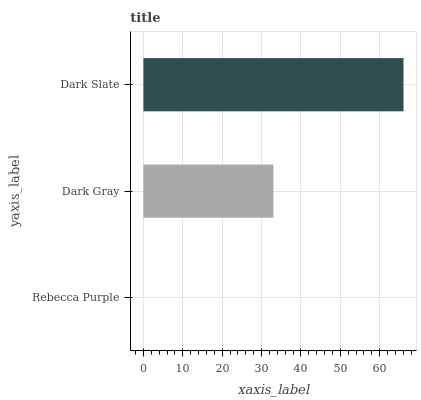Is Rebecca Purple the minimum?
Answer yes or no. Yes. Is Dark Slate the maximum?
Answer yes or no. Yes. Is Dark Gray the minimum?
Answer yes or no. No. Is Dark Gray the maximum?
Answer yes or no. No. Is Dark Gray greater than Rebecca Purple?
Answer yes or no. Yes. Is Rebecca Purple less than Dark Gray?
Answer yes or no. Yes. Is Rebecca Purple greater than Dark Gray?
Answer yes or no. No. Is Dark Gray less than Rebecca Purple?
Answer yes or no. No. Is Dark Gray the high median?
Answer yes or no. Yes. Is Dark Gray the low median?
Answer yes or no. Yes. Is Dark Slate the high median?
Answer yes or no. No. Is Rebecca Purple the low median?
Answer yes or no. No. 